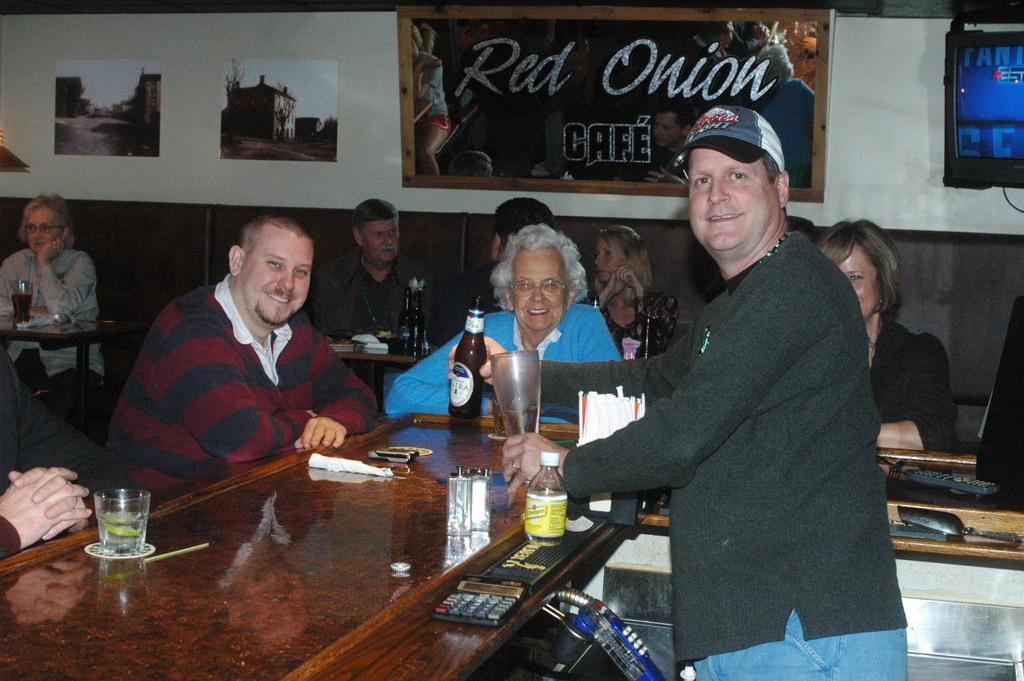How would you summarize this image in a sentence or two? Board, television and posters on wall. Most of the persons are sitting on chairs. In-front of them there are tables, on this tables there are bottles, glasses, calculate and remote. This man wore cap and holding glass and bottle. These persons are smiling. 